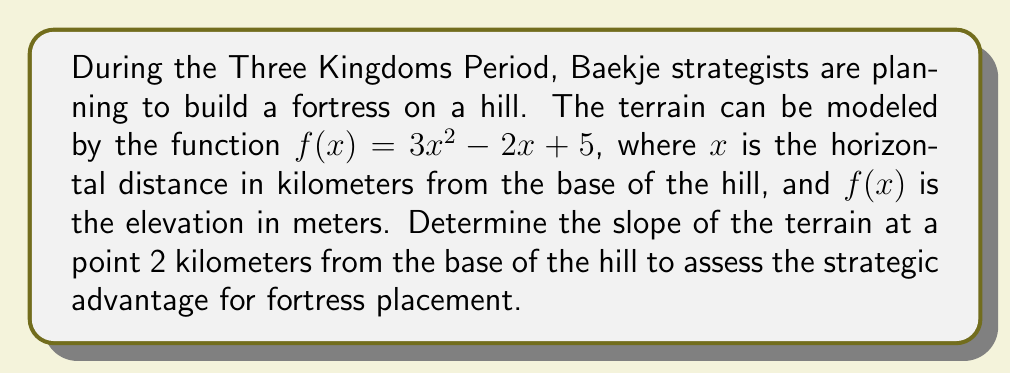Give your solution to this math problem. To find the slope of the terrain at a specific point, we need to calculate the derivative of the function $f(x)$ and then evaluate it at the given point.

1) The function describing the terrain is:
   $f(x) = 3x^2 - 2x + 5$

2) To find the derivative, we use the power rule and the constant rule:
   $f'(x) = 6x - 2$

3) The question asks for the slope at a point 2 kilometers from the base, so we need to evaluate $f'(2)$:
   $f'(2) = 6(2) - 2$
   $f'(2) = 12 - 2 = 10$

4) The slope at $x = 2$ is 10, which means for every 1 kilometer of horizontal distance at this point, the elevation increases by 10 meters.

This steep slope would provide a significant strategic advantage for a Baekje fortress, offering a clear view of approaching enemies and making it difficult for them to attack uphill.
Answer: $10$ meters per kilometer 